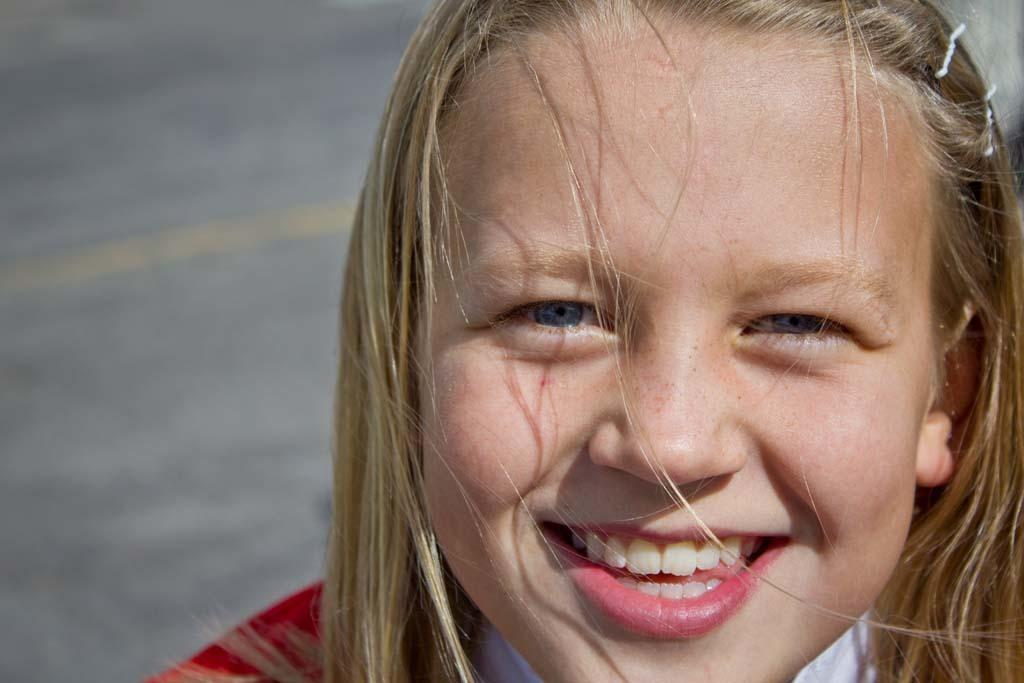Who is in the image? There is a girl in the image. What is the girl doing in the image? The girl is smiling and looking at the picture. What can be seen in the background of the image? There is a road in the background of the image. What type of wax is the girl using to create a sculpture in the image? There is no wax or sculpture present in the image; the girl is simply smiling and looking at the picture. 